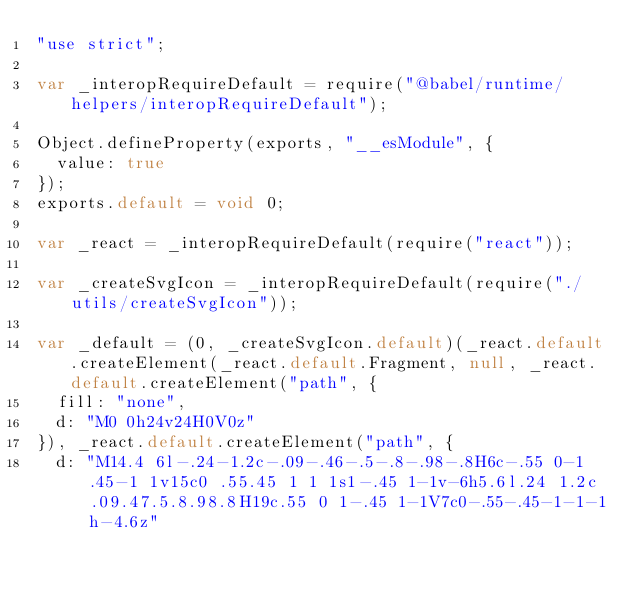Convert code to text. <code><loc_0><loc_0><loc_500><loc_500><_JavaScript_>"use strict";

var _interopRequireDefault = require("@babel/runtime/helpers/interopRequireDefault");

Object.defineProperty(exports, "__esModule", {
  value: true
});
exports.default = void 0;

var _react = _interopRequireDefault(require("react"));

var _createSvgIcon = _interopRequireDefault(require("./utils/createSvgIcon"));

var _default = (0, _createSvgIcon.default)(_react.default.createElement(_react.default.Fragment, null, _react.default.createElement("path", {
  fill: "none",
  d: "M0 0h24v24H0V0z"
}), _react.default.createElement("path", {
  d: "M14.4 6l-.24-1.2c-.09-.46-.5-.8-.98-.8H6c-.55 0-1 .45-1 1v15c0 .55.45 1 1 1s1-.45 1-1v-6h5.6l.24 1.2c.09.47.5.8.98.8H19c.55 0 1-.45 1-1V7c0-.55-.45-1-1-1h-4.6z"</code> 